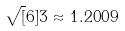Convert formula to latex. <formula><loc_0><loc_0><loc_500><loc_500>\sqrt { [ } 6 ] { 3 } \approx 1 . 2 0 0 9</formula> 